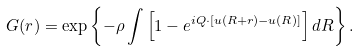Convert formula to latex. <formula><loc_0><loc_0><loc_500><loc_500>G ( r ) = \exp \left \{ - \rho \int \left [ 1 - e ^ { i Q \cdot [ u ( R + r ) - u ( R ) ] } \right ] d R \right \} .</formula> 